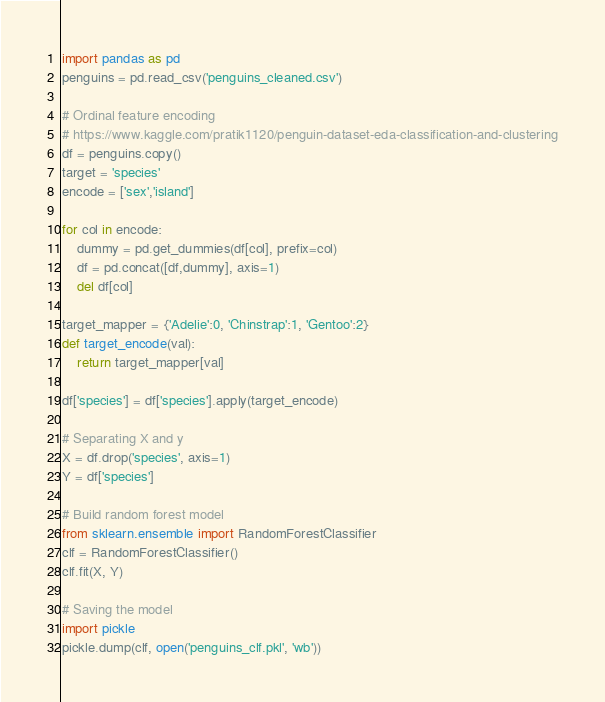Convert code to text. <code><loc_0><loc_0><loc_500><loc_500><_Python_>import pandas as pd
penguins = pd.read_csv('penguins_cleaned.csv')

# Ordinal feature encoding
# https://www.kaggle.com/pratik1120/penguin-dataset-eda-classification-and-clustering
df = penguins.copy()
target = 'species'
encode = ['sex','island']

for col in encode:
    dummy = pd.get_dummies(df[col], prefix=col)
    df = pd.concat([df,dummy], axis=1)
    del df[col]

target_mapper = {'Adelie':0, 'Chinstrap':1, 'Gentoo':2}
def target_encode(val):
    return target_mapper[val]

df['species'] = df['species'].apply(target_encode)

# Separating X and y
X = df.drop('species', axis=1)
Y = df['species']

# Build random forest model
from sklearn.ensemble import RandomForestClassifier
clf = RandomForestClassifier()
clf.fit(X, Y)

# Saving the model
import pickle
pickle.dump(clf, open('penguins_clf.pkl', 'wb'))</code> 